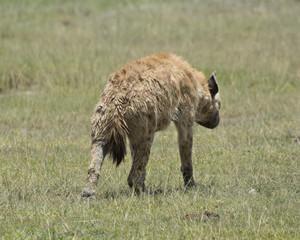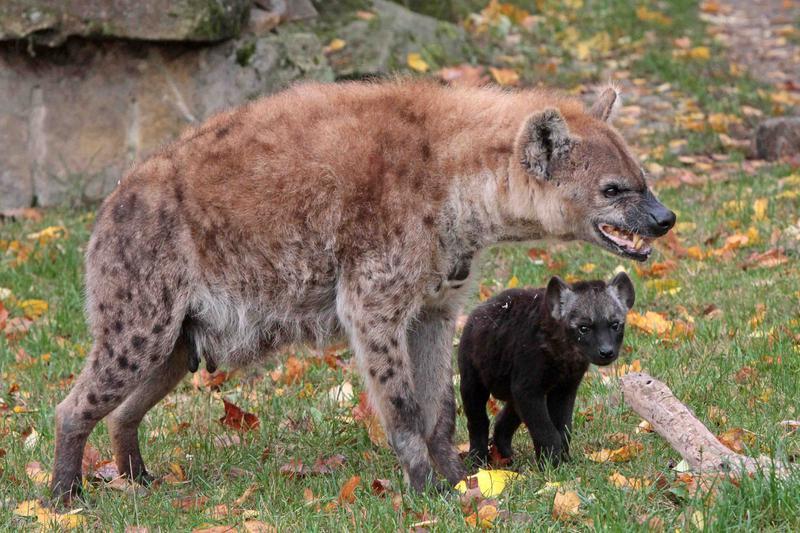The first image is the image on the left, the second image is the image on the right. Considering the images on both sides, is "More animals are in the image on the right." valid? Answer yes or no. Yes. 